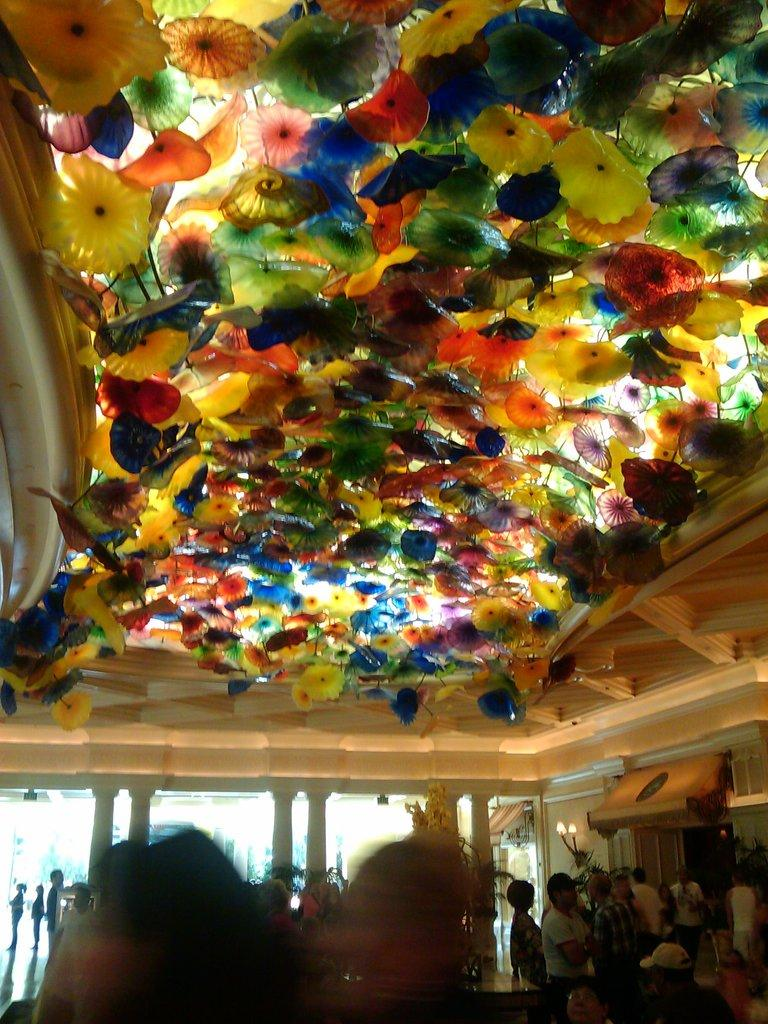What is happening in the hall in the image? There are people standing in the hall in the image. What can be seen on the ceiling in the image? There are colorful objects on the ceiling in the image. What type of bushes can be seen growing in the hall in the image? There are no bushes present in the hall in the image. What type of learning is taking place in the hall in the image? There is no indication of any learning activity taking place in the hall in the image. 